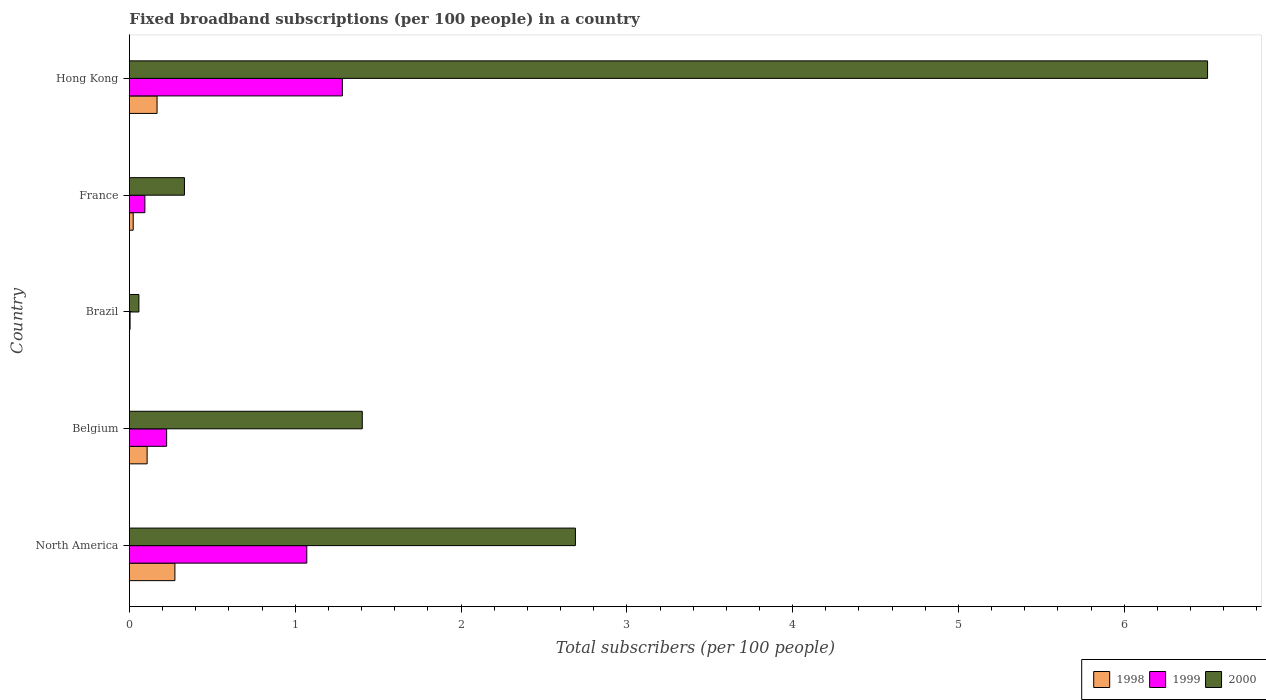How many different coloured bars are there?
Offer a terse response. 3. How many groups of bars are there?
Your answer should be compact. 5. How many bars are there on the 4th tick from the bottom?
Your answer should be very brief. 3. What is the label of the 2nd group of bars from the top?
Give a very brief answer. France. In how many cases, is the number of bars for a given country not equal to the number of legend labels?
Your answer should be compact. 0. What is the number of broadband subscriptions in 1998 in North America?
Your answer should be very brief. 0.27. Across all countries, what is the maximum number of broadband subscriptions in 1998?
Give a very brief answer. 0.27. Across all countries, what is the minimum number of broadband subscriptions in 1999?
Your answer should be very brief. 0. In which country was the number of broadband subscriptions in 1999 maximum?
Offer a terse response. Hong Kong. In which country was the number of broadband subscriptions in 2000 minimum?
Make the answer very short. Brazil. What is the total number of broadband subscriptions in 1998 in the graph?
Ensure brevity in your answer.  0.57. What is the difference between the number of broadband subscriptions in 1999 in Brazil and that in Hong Kong?
Provide a short and direct response. -1.28. What is the difference between the number of broadband subscriptions in 2000 in North America and the number of broadband subscriptions in 1998 in Brazil?
Provide a short and direct response. 2.69. What is the average number of broadband subscriptions in 2000 per country?
Ensure brevity in your answer.  2.2. What is the difference between the number of broadband subscriptions in 1998 and number of broadband subscriptions in 2000 in Belgium?
Your response must be concise. -1.3. What is the ratio of the number of broadband subscriptions in 1999 in Belgium to that in Brazil?
Give a very brief answer. 55.18. Is the difference between the number of broadband subscriptions in 1998 in France and Hong Kong greater than the difference between the number of broadband subscriptions in 2000 in France and Hong Kong?
Make the answer very short. Yes. What is the difference between the highest and the second highest number of broadband subscriptions in 2000?
Provide a succinct answer. 3.81. What is the difference between the highest and the lowest number of broadband subscriptions in 1998?
Offer a very short reply. 0.27. Is the sum of the number of broadband subscriptions in 1999 in Brazil and France greater than the maximum number of broadband subscriptions in 2000 across all countries?
Offer a terse response. No. Is it the case that in every country, the sum of the number of broadband subscriptions in 2000 and number of broadband subscriptions in 1999 is greater than the number of broadband subscriptions in 1998?
Your response must be concise. Yes. How many bars are there?
Keep it short and to the point. 15. Are the values on the major ticks of X-axis written in scientific E-notation?
Ensure brevity in your answer.  No. Where does the legend appear in the graph?
Your response must be concise. Bottom right. How many legend labels are there?
Your answer should be compact. 3. How are the legend labels stacked?
Your response must be concise. Horizontal. What is the title of the graph?
Your answer should be very brief. Fixed broadband subscriptions (per 100 people) in a country. Does "1979" appear as one of the legend labels in the graph?
Provide a succinct answer. No. What is the label or title of the X-axis?
Provide a short and direct response. Total subscribers (per 100 people). What is the label or title of the Y-axis?
Your answer should be compact. Country. What is the Total subscribers (per 100 people) in 1998 in North America?
Your answer should be very brief. 0.27. What is the Total subscribers (per 100 people) in 1999 in North America?
Keep it short and to the point. 1.07. What is the Total subscribers (per 100 people) in 2000 in North America?
Your response must be concise. 2.69. What is the Total subscribers (per 100 people) in 1998 in Belgium?
Ensure brevity in your answer.  0.11. What is the Total subscribers (per 100 people) of 1999 in Belgium?
Your response must be concise. 0.22. What is the Total subscribers (per 100 people) in 2000 in Belgium?
Provide a succinct answer. 1.4. What is the Total subscribers (per 100 people) of 1998 in Brazil?
Offer a very short reply. 0. What is the Total subscribers (per 100 people) in 1999 in Brazil?
Make the answer very short. 0. What is the Total subscribers (per 100 people) in 2000 in Brazil?
Provide a short and direct response. 0.06. What is the Total subscribers (per 100 people) in 1998 in France?
Your answer should be compact. 0.02. What is the Total subscribers (per 100 people) in 1999 in France?
Ensure brevity in your answer.  0.09. What is the Total subscribers (per 100 people) of 2000 in France?
Provide a succinct answer. 0.33. What is the Total subscribers (per 100 people) in 1998 in Hong Kong?
Your answer should be compact. 0.17. What is the Total subscribers (per 100 people) of 1999 in Hong Kong?
Make the answer very short. 1.28. What is the Total subscribers (per 100 people) of 2000 in Hong Kong?
Offer a terse response. 6.5. Across all countries, what is the maximum Total subscribers (per 100 people) in 1998?
Your response must be concise. 0.27. Across all countries, what is the maximum Total subscribers (per 100 people) in 1999?
Your answer should be compact. 1.28. Across all countries, what is the maximum Total subscribers (per 100 people) of 2000?
Make the answer very short. 6.5. Across all countries, what is the minimum Total subscribers (per 100 people) of 1998?
Offer a very short reply. 0. Across all countries, what is the minimum Total subscribers (per 100 people) in 1999?
Provide a short and direct response. 0. Across all countries, what is the minimum Total subscribers (per 100 people) in 2000?
Your answer should be compact. 0.06. What is the total Total subscribers (per 100 people) in 1998 in the graph?
Offer a terse response. 0.57. What is the total Total subscribers (per 100 people) of 1999 in the graph?
Your answer should be very brief. 2.68. What is the total Total subscribers (per 100 people) in 2000 in the graph?
Ensure brevity in your answer.  10.99. What is the difference between the Total subscribers (per 100 people) in 1998 in North America and that in Belgium?
Give a very brief answer. 0.17. What is the difference between the Total subscribers (per 100 people) in 1999 in North America and that in Belgium?
Provide a short and direct response. 0.85. What is the difference between the Total subscribers (per 100 people) of 2000 in North America and that in Belgium?
Ensure brevity in your answer.  1.29. What is the difference between the Total subscribers (per 100 people) of 1998 in North America and that in Brazil?
Your answer should be compact. 0.27. What is the difference between the Total subscribers (per 100 people) in 1999 in North America and that in Brazil?
Keep it short and to the point. 1.07. What is the difference between the Total subscribers (per 100 people) in 2000 in North America and that in Brazil?
Offer a terse response. 2.63. What is the difference between the Total subscribers (per 100 people) of 1998 in North America and that in France?
Your answer should be very brief. 0.25. What is the difference between the Total subscribers (per 100 people) in 1999 in North America and that in France?
Provide a short and direct response. 0.98. What is the difference between the Total subscribers (per 100 people) of 2000 in North America and that in France?
Keep it short and to the point. 2.36. What is the difference between the Total subscribers (per 100 people) in 1998 in North America and that in Hong Kong?
Make the answer very short. 0.11. What is the difference between the Total subscribers (per 100 people) in 1999 in North America and that in Hong Kong?
Provide a succinct answer. -0.21. What is the difference between the Total subscribers (per 100 people) of 2000 in North America and that in Hong Kong?
Offer a terse response. -3.81. What is the difference between the Total subscribers (per 100 people) of 1998 in Belgium and that in Brazil?
Your response must be concise. 0.11. What is the difference between the Total subscribers (per 100 people) in 1999 in Belgium and that in Brazil?
Keep it short and to the point. 0.22. What is the difference between the Total subscribers (per 100 people) in 2000 in Belgium and that in Brazil?
Your answer should be compact. 1.35. What is the difference between the Total subscribers (per 100 people) in 1998 in Belgium and that in France?
Keep it short and to the point. 0.08. What is the difference between the Total subscribers (per 100 people) in 1999 in Belgium and that in France?
Provide a succinct answer. 0.13. What is the difference between the Total subscribers (per 100 people) of 2000 in Belgium and that in France?
Make the answer very short. 1.07. What is the difference between the Total subscribers (per 100 people) in 1998 in Belgium and that in Hong Kong?
Provide a succinct answer. -0.06. What is the difference between the Total subscribers (per 100 people) of 1999 in Belgium and that in Hong Kong?
Give a very brief answer. -1.06. What is the difference between the Total subscribers (per 100 people) of 2000 in Belgium and that in Hong Kong?
Provide a succinct answer. -5.1. What is the difference between the Total subscribers (per 100 people) in 1998 in Brazil and that in France?
Offer a terse response. -0.02. What is the difference between the Total subscribers (per 100 people) in 1999 in Brazil and that in France?
Your answer should be compact. -0.09. What is the difference between the Total subscribers (per 100 people) in 2000 in Brazil and that in France?
Provide a succinct answer. -0.27. What is the difference between the Total subscribers (per 100 people) of 1998 in Brazil and that in Hong Kong?
Provide a succinct answer. -0.17. What is the difference between the Total subscribers (per 100 people) in 1999 in Brazil and that in Hong Kong?
Make the answer very short. -1.28. What is the difference between the Total subscribers (per 100 people) of 2000 in Brazil and that in Hong Kong?
Make the answer very short. -6.45. What is the difference between the Total subscribers (per 100 people) of 1998 in France and that in Hong Kong?
Your answer should be compact. -0.14. What is the difference between the Total subscribers (per 100 people) of 1999 in France and that in Hong Kong?
Keep it short and to the point. -1.19. What is the difference between the Total subscribers (per 100 people) in 2000 in France and that in Hong Kong?
Your answer should be compact. -6.17. What is the difference between the Total subscribers (per 100 people) of 1998 in North America and the Total subscribers (per 100 people) of 1999 in Belgium?
Your answer should be compact. 0.05. What is the difference between the Total subscribers (per 100 people) in 1998 in North America and the Total subscribers (per 100 people) in 2000 in Belgium?
Offer a very short reply. -1.13. What is the difference between the Total subscribers (per 100 people) in 1999 in North America and the Total subscribers (per 100 people) in 2000 in Belgium?
Provide a succinct answer. -0.33. What is the difference between the Total subscribers (per 100 people) of 1998 in North America and the Total subscribers (per 100 people) of 1999 in Brazil?
Keep it short and to the point. 0.27. What is the difference between the Total subscribers (per 100 people) in 1998 in North America and the Total subscribers (per 100 people) in 2000 in Brazil?
Your response must be concise. 0.22. What is the difference between the Total subscribers (per 100 people) in 1999 in North America and the Total subscribers (per 100 people) in 2000 in Brazil?
Give a very brief answer. 1.01. What is the difference between the Total subscribers (per 100 people) in 1998 in North America and the Total subscribers (per 100 people) in 1999 in France?
Give a very brief answer. 0.18. What is the difference between the Total subscribers (per 100 people) in 1998 in North America and the Total subscribers (per 100 people) in 2000 in France?
Your response must be concise. -0.06. What is the difference between the Total subscribers (per 100 people) in 1999 in North America and the Total subscribers (per 100 people) in 2000 in France?
Keep it short and to the point. 0.74. What is the difference between the Total subscribers (per 100 people) of 1998 in North America and the Total subscribers (per 100 people) of 1999 in Hong Kong?
Offer a terse response. -1.01. What is the difference between the Total subscribers (per 100 people) of 1998 in North America and the Total subscribers (per 100 people) of 2000 in Hong Kong?
Make the answer very short. -6.23. What is the difference between the Total subscribers (per 100 people) in 1999 in North America and the Total subscribers (per 100 people) in 2000 in Hong Kong?
Provide a succinct answer. -5.43. What is the difference between the Total subscribers (per 100 people) of 1998 in Belgium and the Total subscribers (per 100 people) of 1999 in Brazil?
Your answer should be very brief. 0.1. What is the difference between the Total subscribers (per 100 people) in 1998 in Belgium and the Total subscribers (per 100 people) in 2000 in Brazil?
Offer a terse response. 0.05. What is the difference between the Total subscribers (per 100 people) of 1999 in Belgium and the Total subscribers (per 100 people) of 2000 in Brazil?
Ensure brevity in your answer.  0.17. What is the difference between the Total subscribers (per 100 people) of 1998 in Belgium and the Total subscribers (per 100 people) of 1999 in France?
Offer a terse response. 0.01. What is the difference between the Total subscribers (per 100 people) in 1998 in Belgium and the Total subscribers (per 100 people) in 2000 in France?
Offer a very short reply. -0.23. What is the difference between the Total subscribers (per 100 people) in 1999 in Belgium and the Total subscribers (per 100 people) in 2000 in France?
Ensure brevity in your answer.  -0.11. What is the difference between the Total subscribers (per 100 people) in 1998 in Belgium and the Total subscribers (per 100 people) in 1999 in Hong Kong?
Make the answer very short. -1.18. What is the difference between the Total subscribers (per 100 people) in 1998 in Belgium and the Total subscribers (per 100 people) in 2000 in Hong Kong?
Make the answer very short. -6.4. What is the difference between the Total subscribers (per 100 people) of 1999 in Belgium and the Total subscribers (per 100 people) of 2000 in Hong Kong?
Make the answer very short. -6.28. What is the difference between the Total subscribers (per 100 people) in 1998 in Brazil and the Total subscribers (per 100 people) in 1999 in France?
Offer a very short reply. -0.09. What is the difference between the Total subscribers (per 100 people) in 1998 in Brazil and the Total subscribers (per 100 people) in 2000 in France?
Ensure brevity in your answer.  -0.33. What is the difference between the Total subscribers (per 100 people) in 1999 in Brazil and the Total subscribers (per 100 people) in 2000 in France?
Provide a short and direct response. -0.33. What is the difference between the Total subscribers (per 100 people) of 1998 in Brazil and the Total subscribers (per 100 people) of 1999 in Hong Kong?
Your response must be concise. -1.28. What is the difference between the Total subscribers (per 100 people) in 1998 in Brazil and the Total subscribers (per 100 people) in 2000 in Hong Kong?
Your response must be concise. -6.5. What is the difference between the Total subscribers (per 100 people) of 1999 in Brazil and the Total subscribers (per 100 people) of 2000 in Hong Kong?
Offer a very short reply. -6.5. What is the difference between the Total subscribers (per 100 people) in 1998 in France and the Total subscribers (per 100 people) in 1999 in Hong Kong?
Offer a very short reply. -1.26. What is the difference between the Total subscribers (per 100 people) of 1998 in France and the Total subscribers (per 100 people) of 2000 in Hong Kong?
Offer a terse response. -6.48. What is the difference between the Total subscribers (per 100 people) in 1999 in France and the Total subscribers (per 100 people) in 2000 in Hong Kong?
Give a very brief answer. -6.41. What is the average Total subscribers (per 100 people) in 1998 per country?
Provide a succinct answer. 0.11. What is the average Total subscribers (per 100 people) of 1999 per country?
Offer a very short reply. 0.54. What is the average Total subscribers (per 100 people) in 2000 per country?
Provide a short and direct response. 2.2. What is the difference between the Total subscribers (per 100 people) in 1998 and Total subscribers (per 100 people) in 1999 in North America?
Provide a succinct answer. -0.8. What is the difference between the Total subscribers (per 100 people) of 1998 and Total subscribers (per 100 people) of 2000 in North America?
Give a very brief answer. -2.42. What is the difference between the Total subscribers (per 100 people) in 1999 and Total subscribers (per 100 people) in 2000 in North America?
Provide a short and direct response. -1.62. What is the difference between the Total subscribers (per 100 people) in 1998 and Total subscribers (per 100 people) in 1999 in Belgium?
Provide a short and direct response. -0.12. What is the difference between the Total subscribers (per 100 people) in 1998 and Total subscribers (per 100 people) in 2000 in Belgium?
Offer a terse response. -1.3. What is the difference between the Total subscribers (per 100 people) of 1999 and Total subscribers (per 100 people) of 2000 in Belgium?
Offer a terse response. -1.18. What is the difference between the Total subscribers (per 100 people) in 1998 and Total subscribers (per 100 people) in 1999 in Brazil?
Your answer should be compact. -0. What is the difference between the Total subscribers (per 100 people) in 1998 and Total subscribers (per 100 people) in 2000 in Brazil?
Your answer should be compact. -0.06. What is the difference between the Total subscribers (per 100 people) in 1999 and Total subscribers (per 100 people) in 2000 in Brazil?
Make the answer very short. -0.05. What is the difference between the Total subscribers (per 100 people) of 1998 and Total subscribers (per 100 people) of 1999 in France?
Offer a terse response. -0.07. What is the difference between the Total subscribers (per 100 people) of 1998 and Total subscribers (per 100 people) of 2000 in France?
Make the answer very short. -0.31. What is the difference between the Total subscribers (per 100 people) in 1999 and Total subscribers (per 100 people) in 2000 in France?
Provide a succinct answer. -0.24. What is the difference between the Total subscribers (per 100 people) in 1998 and Total subscribers (per 100 people) in 1999 in Hong Kong?
Provide a short and direct response. -1.12. What is the difference between the Total subscribers (per 100 people) of 1998 and Total subscribers (per 100 people) of 2000 in Hong Kong?
Make the answer very short. -6.34. What is the difference between the Total subscribers (per 100 people) in 1999 and Total subscribers (per 100 people) in 2000 in Hong Kong?
Ensure brevity in your answer.  -5.22. What is the ratio of the Total subscribers (per 100 people) of 1998 in North America to that in Belgium?
Offer a very short reply. 2.57. What is the ratio of the Total subscribers (per 100 people) in 1999 in North America to that in Belgium?
Your answer should be compact. 4.76. What is the ratio of the Total subscribers (per 100 people) of 2000 in North America to that in Belgium?
Offer a terse response. 1.92. What is the ratio of the Total subscribers (per 100 people) of 1998 in North America to that in Brazil?
Offer a terse response. 465.15. What is the ratio of the Total subscribers (per 100 people) in 1999 in North America to that in Brazil?
Provide a succinct answer. 262.9. What is the ratio of the Total subscribers (per 100 people) of 2000 in North America to that in Brazil?
Offer a very short reply. 46.94. What is the ratio of the Total subscribers (per 100 people) of 1998 in North America to that in France?
Offer a terse response. 11.95. What is the ratio of the Total subscribers (per 100 people) of 1999 in North America to that in France?
Offer a very short reply. 11.46. What is the ratio of the Total subscribers (per 100 people) in 2000 in North America to that in France?
Provide a short and direct response. 8.1. What is the ratio of the Total subscribers (per 100 people) in 1998 in North America to that in Hong Kong?
Offer a terse response. 1.64. What is the ratio of the Total subscribers (per 100 people) of 1999 in North America to that in Hong Kong?
Provide a short and direct response. 0.83. What is the ratio of the Total subscribers (per 100 people) in 2000 in North America to that in Hong Kong?
Offer a terse response. 0.41. What is the ratio of the Total subscribers (per 100 people) of 1998 in Belgium to that in Brazil?
Your answer should be very brief. 181.1. What is the ratio of the Total subscribers (per 100 people) of 1999 in Belgium to that in Brazil?
Keep it short and to the point. 55.18. What is the ratio of the Total subscribers (per 100 people) in 2000 in Belgium to that in Brazil?
Keep it short and to the point. 24.51. What is the ratio of the Total subscribers (per 100 people) in 1998 in Belgium to that in France?
Give a very brief answer. 4.65. What is the ratio of the Total subscribers (per 100 people) in 1999 in Belgium to that in France?
Offer a very short reply. 2.4. What is the ratio of the Total subscribers (per 100 people) of 2000 in Belgium to that in France?
Provide a short and direct response. 4.23. What is the ratio of the Total subscribers (per 100 people) in 1998 in Belgium to that in Hong Kong?
Ensure brevity in your answer.  0.64. What is the ratio of the Total subscribers (per 100 people) of 1999 in Belgium to that in Hong Kong?
Keep it short and to the point. 0.17. What is the ratio of the Total subscribers (per 100 people) of 2000 in Belgium to that in Hong Kong?
Give a very brief answer. 0.22. What is the ratio of the Total subscribers (per 100 people) of 1998 in Brazil to that in France?
Give a very brief answer. 0.03. What is the ratio of the Total subscribers (per 100 people) in 1999 in Brazil to that in France?
Offer a very short reply. 0.04. What is the ratio of the Total subscribers (per 100 people) in 2000 in Brazil to that in France?
Keep it short and to the point. 0.17. What is the ratio of the Total subscribers (per 100 people) in 1998 in Brazil to that in Hong Kong?
Your answer should be compact. 0. What is the ratio of the Total subscribers (per 100 people) in 1999 in Brazil to that in Hong Kong?
Make the answer very short. 0. What is the ratio of the Total subscribers (per 100 people) in 2000 in Brazil to that in Hong Kong?
Make the answer very short. 0.01. What is the ratio of the Total subscribers (per 100 people) of 1998 in France to that in Hong Kong?
Provide a short and direct response. 0.14. What is the ratio of the Total subscribers (per 100 people) in 1999 in France to that in Hong Kong?
Your response must be concise. 0.07. What is the ratio of the Total subscribers (per 100 people) in 2000 in France to that in Hong Kong?
Offer a terse response. 0.05. What is the difference between the highest and the second highest Total subscribers (per 100 people) in 1998?
Your answer should be compact. 0.11. What is the difference between the highest and the second highest Total subscribers (per 100 people) of 1999?
Offer a very short reply. 0.21. What is the difference between the highest and the second highest Total subscribers (per 100 people) of 2000?
Keep it short and to the point. 3.81. What is the difference between the highest and the lowest Total subscribers (per 100 people) of 1998?
Offer a very short reply. 0.27. What is the difference between the highest and the lowest Total subscribers (per 100 people) of 1999?
Offer a very short reply. 1.28. What is the difference between the highest and the lowest Total subscribers (per 100 people) in 2000?
Offer a terse response. 6.45. 